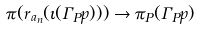Convert formula to latex. <formula><loc_0><loc_0><loc_500><loc_500>\pi ( r _ { a _ { n } } ( \iota ( \Gamma _ { P } p ) ) ) \rightarrow \pi _ { P } ( \Gamma _ { P } p )</formula> 